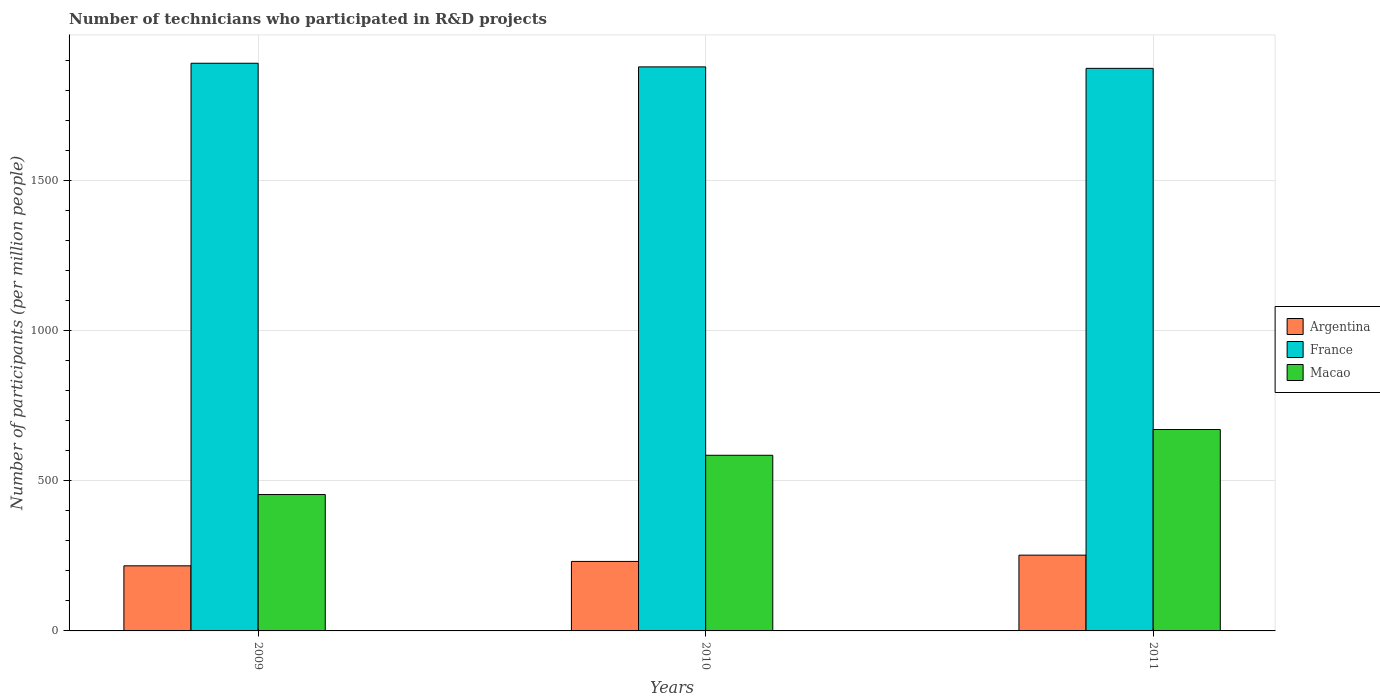How many different coloured bars are there?
Your answer should be compact. 3. Are the number of bars per tick equal to the number of legend labels?
Your response must be concise. Yes. Are the number of bars on each tick of the X-axis equal?
Make the answer very short. Yes. How many bars are there on the 3rd tick from the right?
Your answer should be very brief. 3. What is the label of the 2nd group of bars from the left?
Your answer should be compact. 2010. What is the number of technicians who participated in R&D projects in Macao in 2011?
Your response must be concise. 671.32. Across all years, what is the maximum number of technicians who participated in R&D projects in Macao?
Keep it short and to the point. 671.32. Across all years, what is the minimum number of technicians who participated in R&D projects in Macao?
Offer a terse response. 454.54. In which year was the number of technicians who participated in R&D projects in France maximum?
Offer a terse response. 2009. In which year was the number of technicians who participated in R&D projects in Argentina minimum?
Give a very brief answer. 2009. What is the total number of technicians who participated in R&D projects in France in the graph?
Provide a succinct answer. 5647.02. What is the difference between the number of technicians who participated in R&D projects in Argentina in 2009 and that in 2011?
Provide a succinct answer. -35.61. What is the difference between the number of technicians who participated in R&D projects in Argentina in 2011 and the number of technicians who participated in R&D projects in France in 2009?
Your answer should be compact. -1639.46. What is the average number of technicians who participated in R&D projects in Argentina per year?
Your answer should be compact. 233.72. In the year 2011, what is the difference between the number of technicians who participated in R&D projects in Argentina and number of technicians who participated in R&D projects in Macao?
Ensure brevity in your answer.  -418.75. What is the ratio of the number of technicians who participated in R&D projects in Argentina in 2010 to that in 2011?
Your answer should be compact. 0.92. What is the difference between the highest and the second highest number of technicians who participated in R&D projects in Argentina?
Your response must be concise. 20.96. What is the difference between the highest and the lowest number of technicians who participated in R&D projects in Macao?
Your answer should be compact. 216.78. What does the 3rd bar from the left in 2009 represents?
Your answer should be very brief. Macao. What does the 1st bar from the right in 2010 represents?
Offer a very short reply. Macao. Is it the case that in every year, the sum of the number of technicians who participated in R&D projects in Argentina and number of technicians who participated in R&D projects in France is greater than the number of technicians who participated in R&D projects in Macao?
Your response must be concise. Yes. How many bars are there?
Provide a succinct answer. 9. Are all the bars in the graph horizontal?
Offer a terse response. No. How many years are there in the graph?
Provide a short and direct response. 3. What is the difference between two consecutive major ticks on the Y-axis?
Provide a short and direct response. 500. Does the graph contain grids?
Offer a terse response. Yes. Where does the legend appear in the graph?
Your response must be concise. Center right. What is the title of the graph?
Your response must be concise. Number of technicians who participated in R&D projects. Does "Tajikistan" appear as one of the legend labels in the graph?
Keep it short and to the point. No. What is the label or title of the X-axis?
Your answer should be very brief. Years. What is the label or title of the Y-axis?
Give a very brief answer. Number of participants (per million people). What is the Number of participants (per million people) in Argentina in 2009?
Give a very brief answer. 216.97. What is the Number of participants (per million people) in France in 2009?
Offer a terse response. 1892.04. What is the Number of participants (per million people) in Macao in 2009?
Provide a short and direct response. 454.54. What is the Number of participants (per million people) in Argentina in 2010?
Keep it short and to the point. 231.62. What is the Number of participants (per million people) of France in 2010?
Offer a very short reply. 1879.95. What is the Number of participants (per million people) in Macao in 2010?
Ensure brevity in your answer.  585.46. What is the Number of participants (per million people) of Argentina in 2011?
Your answer should be compact. 252.58. What is the Number of participants (per million people) in France in 2011?
Your response must be concise. 1875.04. What is the Number of participants (per million people) of Macao in 2011?
Make the answer very short. 671.32. Across all years, what is the maximum Number of participants (per million people) of Argentina?
Your response must be concise. 252.58. Across all years, what is the maximum Number of participants (per million people) of France?
Provide a succinct answer. 1892.04. Across all years, what is the maximum Number of participants (per million people) in Macao?
Your response must be concise. 671.32. Across all years, what is the minimum Number of participants (per million people) in Argentina?
Keep it short and to the point. 216.97. Across all years, what is the minimum Number of participants (per million people) of France?
Give a very brief answer. 1875.04. Across all years, what is the minimum Number of participants (per million people) in Macao?
Offer a very short reply. 454.54. What is the total Number of participants (per million people) in Argentina in the graph?
Provide a succinct answer. 701.16. What is the total Number of participants (per million people) of France in the graph?
Your response must be concise. 5647.02. What is the total Number of participants (per million people) in Macao in the graph?
Provide a succinct answer. 1711.32. What is the difference between the Number of participants (per million people) of Argentina in 2009 and that in 2010?
Make the answer very short. -14.65. What is the difference between the Number of participants (per million people) in France in 2009 and that in 2010?
Offer a terse response. 12.09. What is the difference between the Number of participants (per million people) of Macao in 2009 and that in 2010?
Ensure brevity in your answer.  -130.91. What is the difference between the Number of participants (per million people) of Argentina in 2009 and that in 2011?
Ensure brevity in your answer.  -35.61. What is the difference between the Number of participants (per million people) in France in 2009 and that in 2011?
Offer a terse response. 17. What is the difference between the Number of participants (per million people) in Macao in 2009 and that in 2011?
Offer a terse response. -216.78. What is the difference between the Number of participants (per million people) of Argentina in 2010 and that in 2011?
Your answer should be very brief. -20.96. What is the difference between the Number of participants (per million people) of France in 2010 and that in 2011?
Give a very brief answer. 4.91. What is the difference between the Number of participants (per million people) in Macao in 2010 and that in 2011?
Your answer should be very brief. -85.87. What is the difference between the Number of participants (per million people) in Argentina in 2009 and the Number of participants (per million people) in France in 2010?
Your answer should be compact. -1662.98. What is the difference between the Number of participants (per million people) in Argentina in 2009 and the Number of participants (per million people) in Macao in 2010?
Make the answer very short. -368.49. What is the difference between the Number of participants (per million people) of France in 2009 and the Number of participants (per million people) of Macao in 2010?
Provide a succinct answer. 1306.58. What is the difference between the Number of participants (per million people) in Argentina in 2009 and the Number of participants (per million people) in France in 2011?
Your response must be concise. -1658.07. What is the difference between the Number of participants (per million people) in Argentina in 2009 and the Number of participants (per million people) in Macao in 2011?
Your answer should be compact. -454.35. What is the difference between the Number of participants (per million people) in France in 2009 and the Number of participants (per million people) in Macao in 2011?
Your answer should be very brief. 1220.72. What is the difference between the Number of participants (per million people) of Argentina in 2010 and the Number of participants (per million people) of France in 2011?
Give a very brief answer. -1643.42. What is the difference between the Number of participants (per million people) of Argentina in 2010 and the Number of participants (per million people) of Macao in 2011?
Make the answer very short. -439.7. What is the difference between the Number of participants (per million people) in France in 2010 and the Number of participants (per million people) in Macao in 2011?
Keep it short and to the point. 1208.62. What is the average Number of participants (per million people) in Argentina per year?
Your response must be concise. 233.72. What is the average Number of participants (per million people) of France per year?
Your answer should be compact. 1882.34. What is the average Number of participants (per million people) of Macao per year?
Offer a very short reply. 570.44. In the year 2009, what is the difference between the Number of participants (per million people) in Argentina and Number of participants (per million people) in France?
Provide a short and direct response. -1675.07. In the year 2009, what is the difference between the Number of participants (per million people) in Argentina and Number of participants (per million people) in Macao?
Ensure brevity in your answer.  -237.57. In the year 2009, what is the difference between the Number of participants (per million people) in France and Number of participants (per million people) in Macao?
Your answer should be very brief. 1437.5. In the year 2010, what is the difference between the Number of participants (per million people) in Argentina and Number of participants (per million people) in France?
Give a very brief answer. -1648.33. In the year 2010, what is the difference between the Number of participants (per million people) in Argentina and Number of participants (per million people) in Macao?
Offer a terse response. -353.84. In the year 2010, what is the difference between the Number of participants (per million people) of France and Number of participants (per million people) of Macao?
Your answer should be very brief. 1294.49. In the year 2011, what is the difference between the Number of participants (per million people) of Argentina and Number of participants (per million people) of France?
Your answer should be compact. -1622.46. In the year 2011, what is the difference between the Number of participants (per million people) in Argentina and Number of participants (per million people) in Macao?
Offer a very short reply. -418.75. In the year 2011, what is the difference between the Number of participants (per million people) in France and Number of participants (per million people) in Macao?
Provide a short and direct response. 1203.72. What is the ratio of the Number of participants (per million people) of Argentina in 2009 to that in 2010?
Provide a succinct answer. 0.94. What is the ratio of the Number of participants (per million people) of France in 2009 to that in 2010?
Provide a succinct answer. 1.01. What is the ratio of the Number of participants (per million people) in Macao in 2009 to that in 2010?
Keep it short and to the point. 0.78. What is the ratio of the Number of participants (per million people) in Argentina in 2009 to that in 2011?
Your answer should be compact. 0.86. What is the ratio of the Number of participants (per million people) of France in 2009 to that in 2011?
Your response must be concise. 1.01. What is the ratio of the Number of participants (per million people) in Macao in 2009 to that in 2011?
Keep it short and to the point. 0.68. What is the ratio of the Number of participants (per million people) in Argentina in 2010 to that in 2011?
Ensure brevity in your answer.  0.92. What is the ratio of the Number of participants (per million people) in Macao in 2010 to that in 2011?
Make the answer very short. 0.87. What is the difference between the highest and the second highest Number of participants (per million people) in Argentina?
Ensure brevity in your answer.  20.96. What is the difference between the highest and the second highest Number of participants (per million people) in France?
Your answer should be very brief. 12.09. What is the difference between the highest and the second highest Number of participants (per million people) in Macao?
Offer a terse response. 85.87. What is the difference between the highest and the lowest Number of participants (per million people) in Argentina?
Your answer should be very brief. 35.61. What is the difference between the highest and the lowest Number of participants (per million people) in France?
Offer a terse response. 17. What is the difference between the highest and the lowest Number of participants (per million people) in Macao?
Your answer should be very brief. 216.78. 